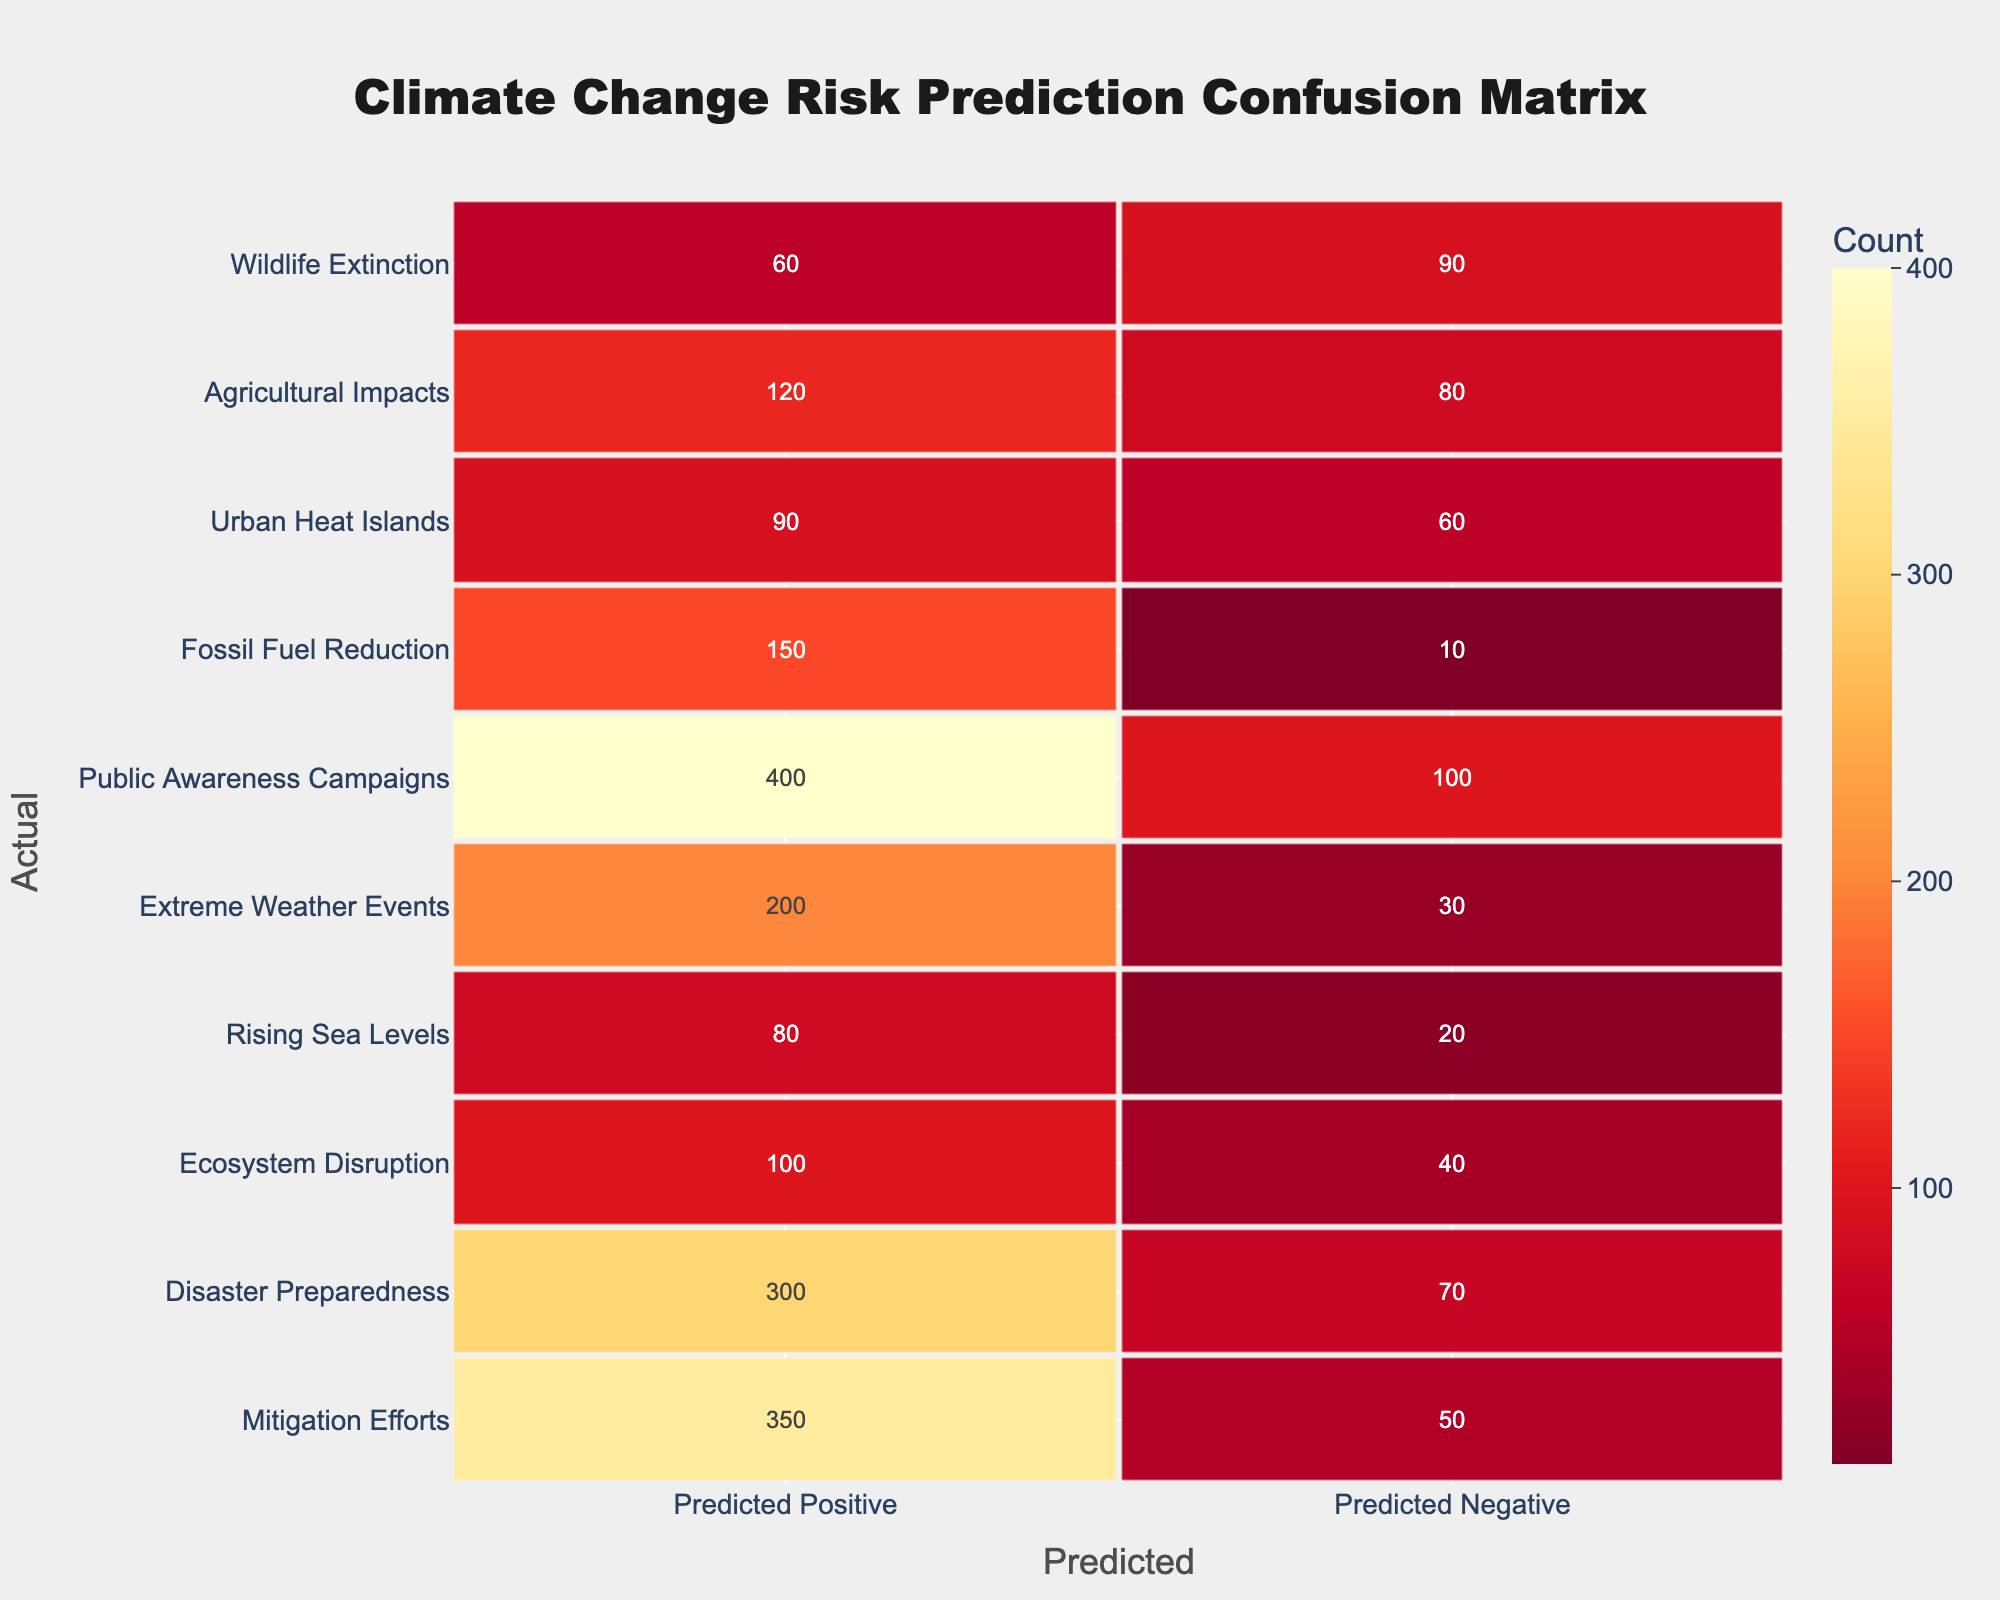What is the count of actual "Rising Sea Levels" predicted positively? According to the table, the count of actual "Rising Sea Levels" predicted positively is 80 under the "Predicted Positive" column for that category.
Answer: 80 What category has the highest count of predicted negatives? Looking at the "Predicted Negative" column, the category "Wildlife Extinction" has the highest count with 90.
Answer: 90 What is the total count of "Public Awareness Campaigns" predicted positively and negatively? The total count for "Public Awareness Campaigns" is the sum of the predicted positive (400) and predicted negative (100) values. This gives us 400 + 100 = 500.
Answer: 500 Is the count of "Extreme Weather Events" predicted positively greater than that of "Urban Heat Islands"? The count of "Extreme Weather Events" predicted positively is 200, while that of "Urban Heat Islands" is 90. Since 200 is greater than 90, the answer is yes.
Answer: Yes What is the difference between the predicted positive and predicted negative for "Ecosystem Disruption"? The count for "Ecosystem Disruption" in the predicted positive is 100, and the predicted negative is 40. The difference is calculated as 100 - 40 = 60.
Answer: 60 What is the average predicted positive count across all categories? To compute the average, we sum all the predicted positive values: 350 + 300 + 100 + 80 + 200 + 400 + 150 + 90 + 120 + 60 = 1930. The number of categories is 10, so the average is 1930 / 10 = 193.
Answer: 193 Which category has the lowest predicted positive count? By reviewing the table, the category "Ecosystem Disruption" has the lowest predicted positive count with a value of 100.
Answer: 100 Is the predicted positive count for "Fossil Fuel Reduction" less than that of "Disaster Preparedness"? The predicted positive count for "Fossil Fuel Reduction" is 150, while for "Disaster Preparedness," it is 300. Since 150 is less than 300, the answer is yes.
Answer: Yes What is the total count of predicted negatives for all categories combined? To find the total predicted negatives, we sum the values in the "Predicted Negative" column: 50 + 70 + 40 + 20 + 30 + 100 + 10 + 60 + 80 + 90 = 450.
Answer: 450 